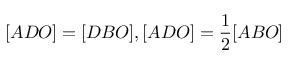Convert formula to latex. <formula><loc_0><loc_0><loc_500><loc_500>[ A D O ] = [ D B O ] , [ A D O ] = { \frac { 1 } { 2 } } [ A B O ]</formula> 